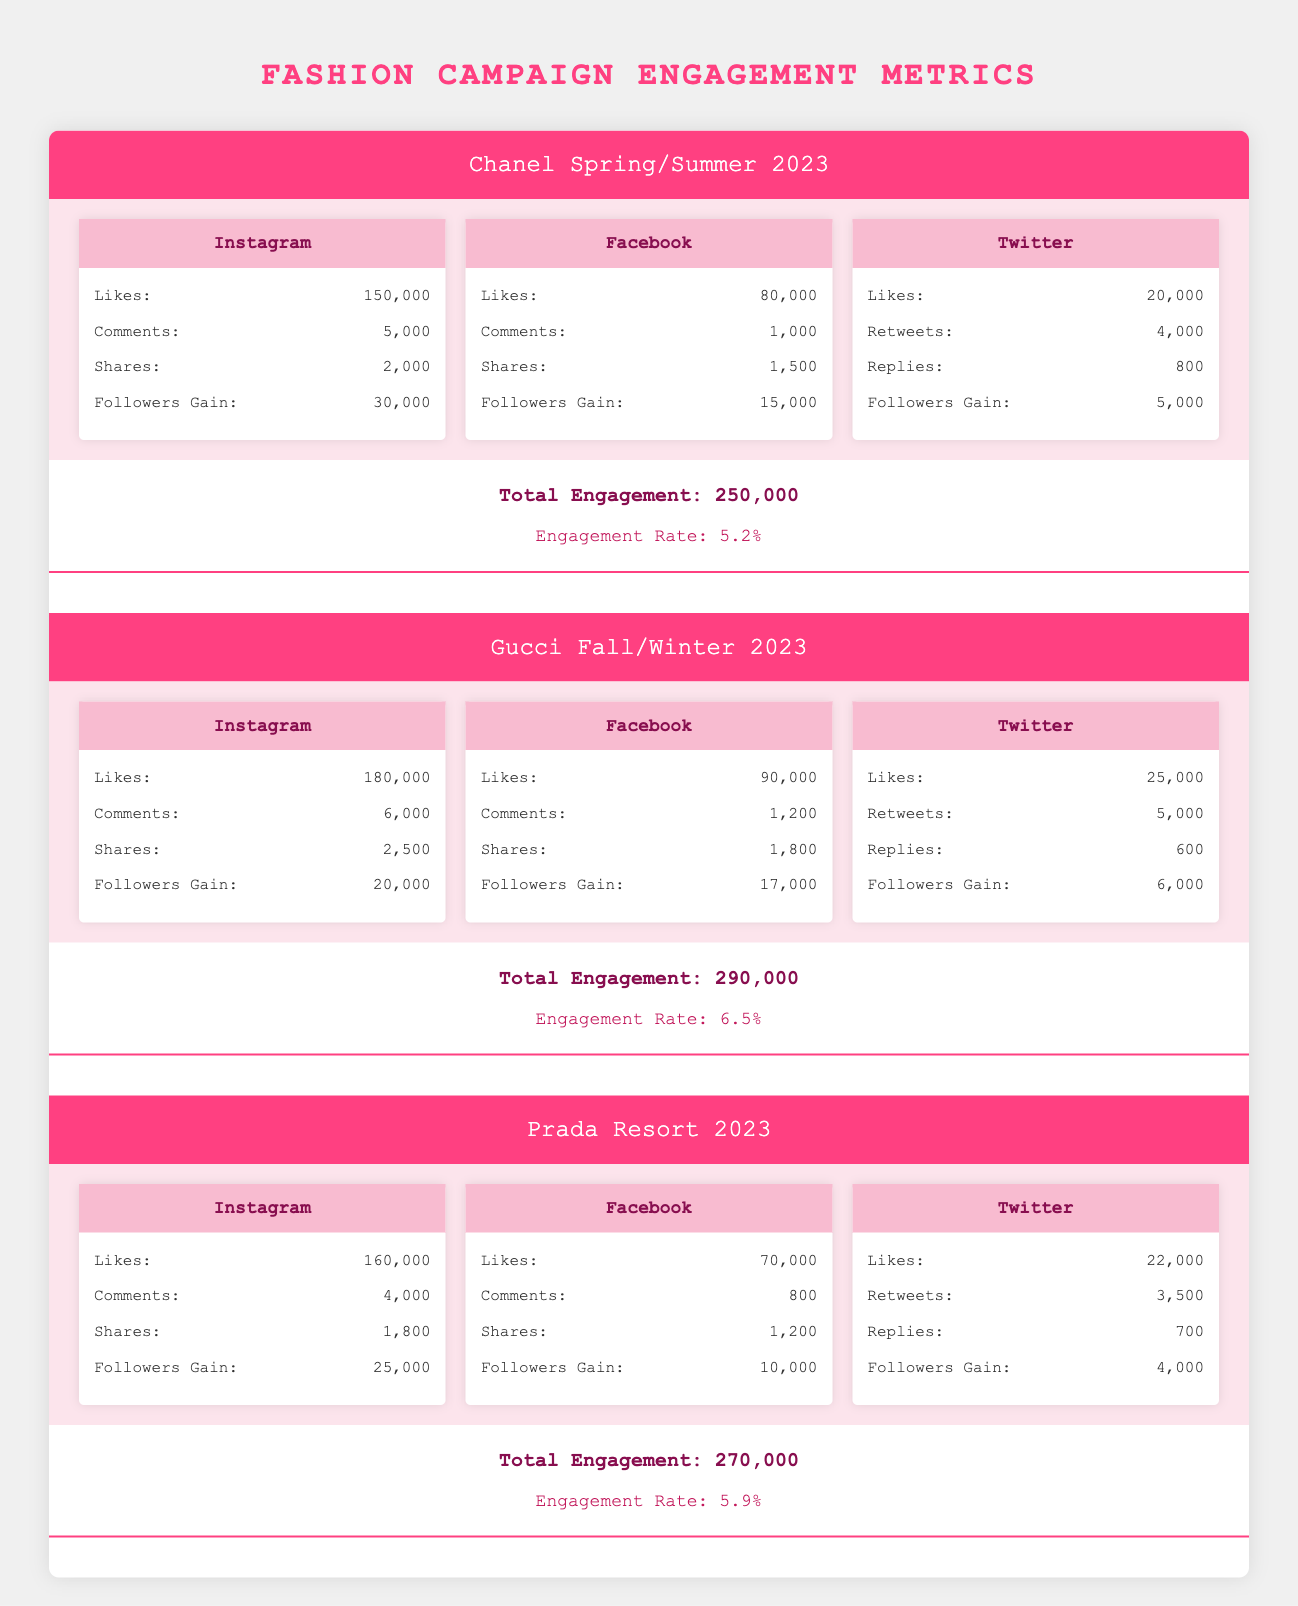What was the total engagement for the Chanel Spring/Summer 2023 campaign? The table states that the total engagement for the Chanel Spring/Summer 2023 campaign is clearly listed as 250,000.
Answer: 250,000 Which platform had the highest number of likes for the Gucci Fall/Winter 2023 campaign? Looking at the engagement data, Instagram has 180,000 likes, which is higher than Facebook with 90,000 and Twitter with 25,000. Thus, Instagram had the highest number of likes.
Answer: Instagram Did the Prada Resort 2023 campaign achieve a total engagement higher than 280,000? The total engagement for the Prada Resort 2023 campaign is recorded as 270,000, which is less than 280,000. Therefore, the statement is false.
Answer: No What is the difference in the total engagement between the Gucci Fall/Winter 2023 and Prada Resort 2023 campaigns? The total engagement was 290,000 for Gucci and 270,000 for Prada. The difference is 290,000 - 270,000 = 20,000.
Answer: 20,000 Which campaign had the lowest engagement rate and what was it? Comparing the engagement rates listed, Chanel Spring/Summer 2023 had an engagement rate of 5.2%, Prada Resort 2023 had 5.9%, and Gucci Fall/Winter 2023 had the highest at 6.5%. Therefore, Chanel has the lowest engagement rate of 5.2%.
Answer: 5.2% 